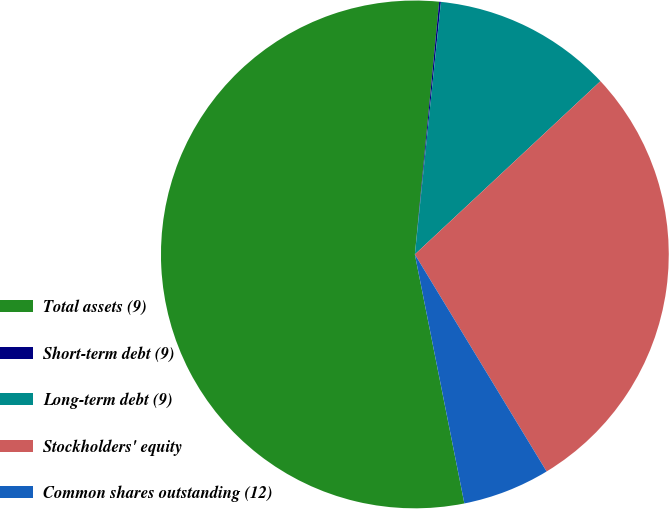Convert chart to OTSL. <chart><loc_0><loc_0><loc_500><loc_500><pie_chart><fcel>Total assets (9)<fcel>Short-term debt (9)<fcel>Long-term debt (9)<fcel>Stockholders' equity<fcel>Common shares outstanding (12)<nl><fcel>54.65%<fcel>0.11%<fcel>11.41%<fcel>28.27%<fcel>5.56%<nl></chart> 